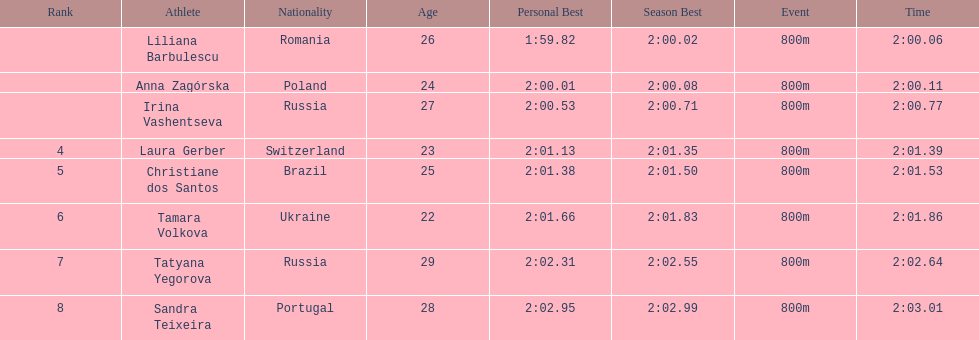Which south american country placed after irina vashentseva? Brazil. 